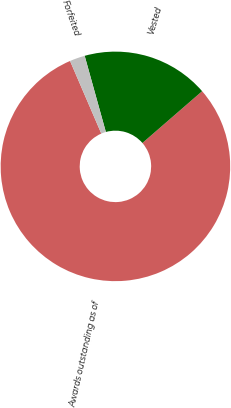Convert chart. <chart><loc_0><loc_0><loc_500><loc_500><pie_chart><fcel>Awards outstanding as of<fcel>Vested<fcel>Forfeited<nl><fcel>79.9%<fcel>17.95%<fcel>2.15%<nl></chart> 